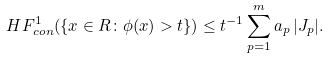Convert formula to latex. <formula><loc_0><loc_0><loc_500><loc_500>H F ^ { 1 } _ { c o n } ( \{ x \in { R } \colon \phi ( x ) > t \} ) \leq t ^ { - 1 } \sum _ { p = 1 } ^ { m } a _ { p } \, | J _ { p } | .</formula> 